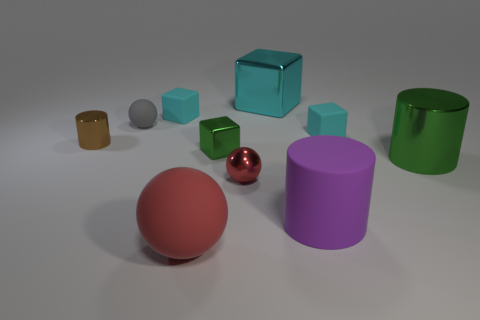Are there any other things of the same color as the large metal cylinder?
Offer a terse response. Yes. Do the big cylinder that is behind the purple matte cylinder and the brown cylinder have the same material?
Your answer should be very brief. Yes. Are there the same number of tiny cyan things to the left of the big red thing and matte spheres that are behind the purple matte cylinder?
Your answer should be compact. Yes. There is a brown shiny thing left of the tiny object in front of the large green metal cylinder; what size is it?
Offer a very short reply. Small. The large thing that is left of the big matte cylinder and in front of the small green thing is made of what material?
Ensure brevity in your answer.  Rubber. How many other things are there of the same size as the gray sphere?
Ensure brevity in your answer.  5. What color is the big metal block?
Your answer should be compact. Cyan. Is the color of the ball that is to the right of the big red thing the same as the matte sphere in front of the tiny gray sphere?
Ensure brevity in your answer.  Yes. How big is the purple object?
Ensure brevity in your answer.  Large. There is a cyan cube that is in front of the small gray object; what is its size?
Provide a succinct answer. Small. 